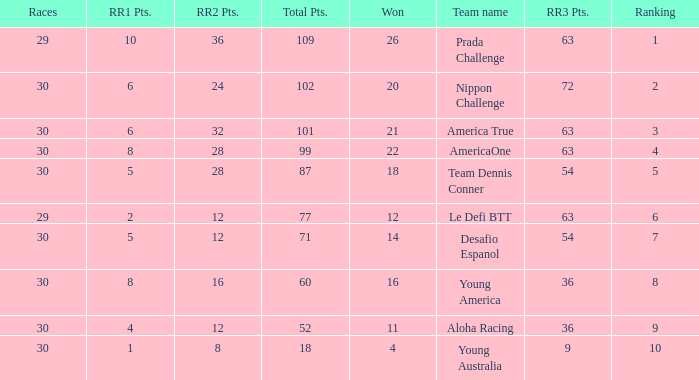State the aggregate quantity of rr2 points for 11 successful outcomes. 1.0. 